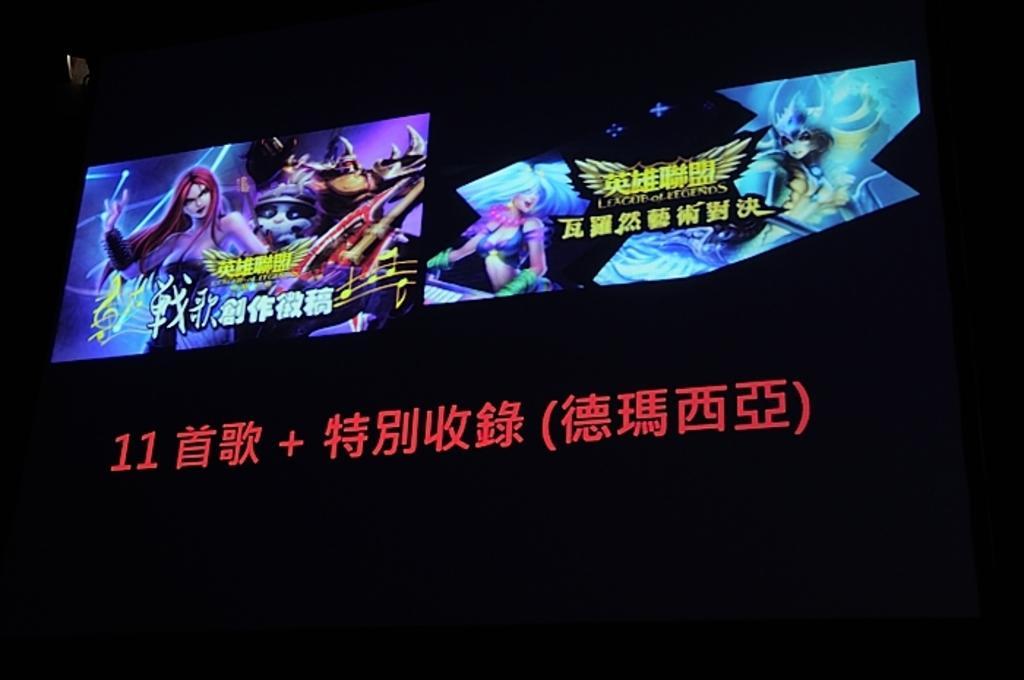How would you summarize this image in a sentence or two? In the center of the picture there is a screen, in the screen there are animations and chinese script. At the bottom there is some chinese text. In the background it is black. 